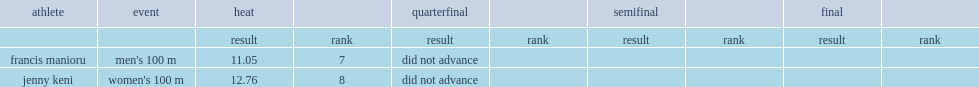How many seconds did francis manioru finish the men's 100 m in seventh place in his heat? 11.05. 